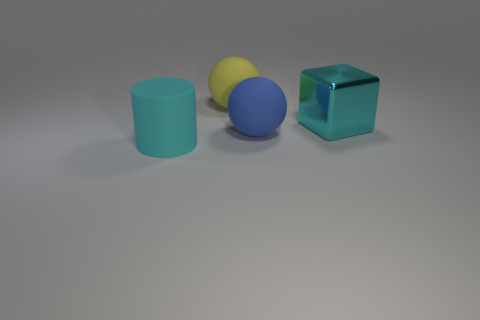How many big cylinders are there?
Your response must be concise. 1. Is there a yellow ball that has the same size as the yellow matte thing?
Your response must be concise. No. Are there fewer big blue objects that are behind the big cylinder than balls?
Offer a very short reply. Yes. Does the block have the same size as the matte cylinder?
Provide a short and direct response. Yes. There is a cyan cylinder that is the same material as the big yellow thing; what size is it?
Your answer should be very brief. Large. What number of things have the same color as the big cube?
Your response must be concise. 1. Is the number of large cyan matte cylinders to the right of the large cyan metal object less than the number of large matte balls that are in front of the yellow matte object?
Ensure brevity in your answer.  Yes. There is a cyan object that is on the right side of the yellow rubber thing; does it have the same shape as the large blue thing?
Give a very brief answer. No. Are there any other things that have the same material as the cube?
Offer a very short reply. No. Is the big cyan object that is in front of the cyan shiny object made of the same material as the block?
Give a very brief answer. No. 